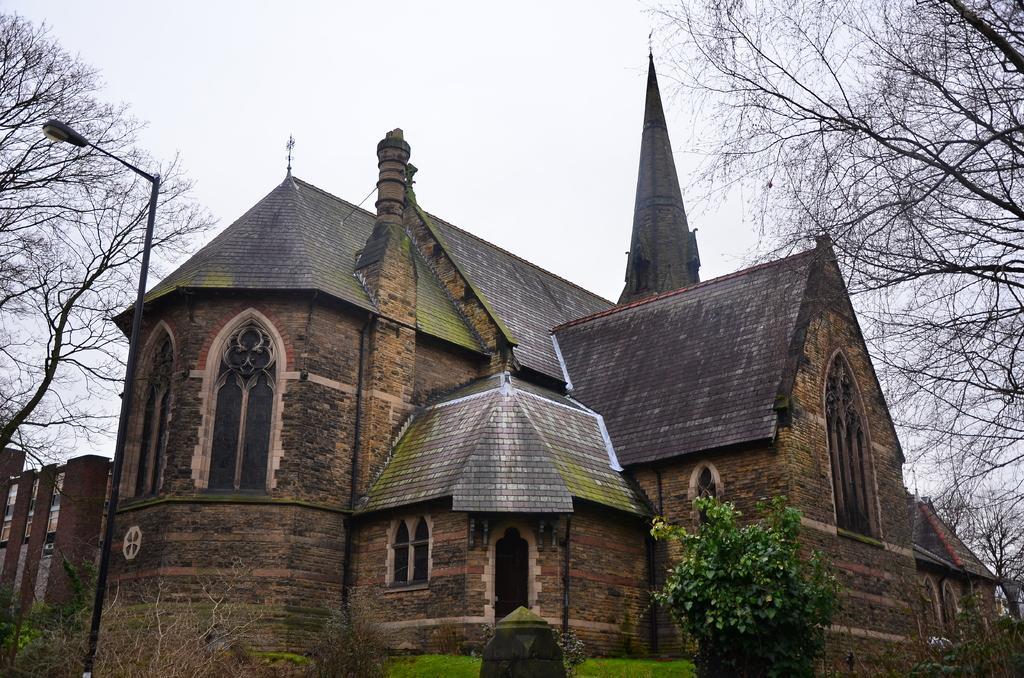Describe this image in one or two sentences. In this image there is a building. In front of the building there are plants and grass on the ground. To the left there is a street light pole. On the either sides of the image there are trees. At the top there is the sky. 